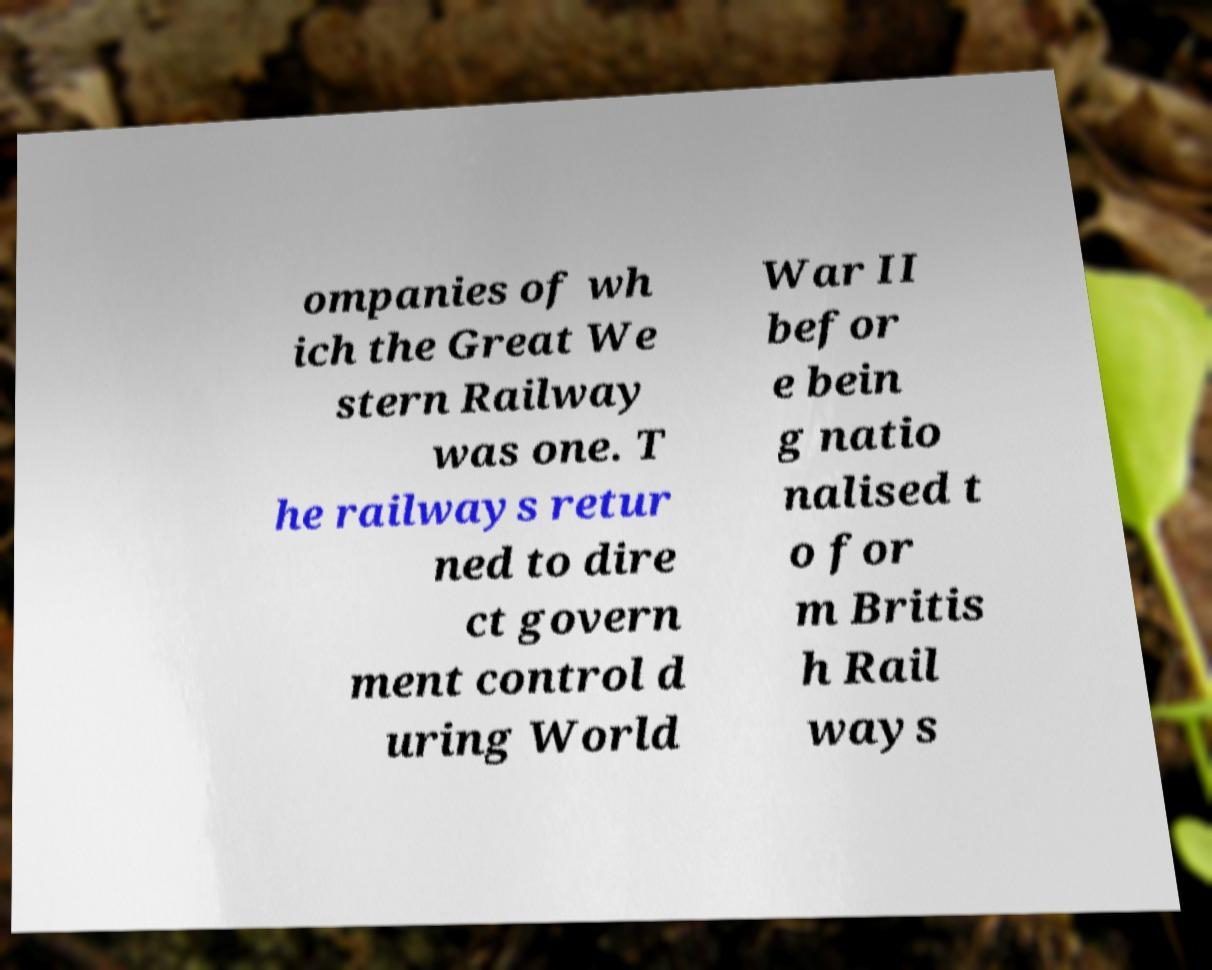Can you read and provide the text displayed in the image?This photo seems to have some interesting text. Can you extract and type it out for me? ompanies of wh ich the Great We stern Railway was one. T he railways retur ned to dire ct govern ment control d uring World War II befor e bein g natio nalised t o for m Britis h Rail ways 